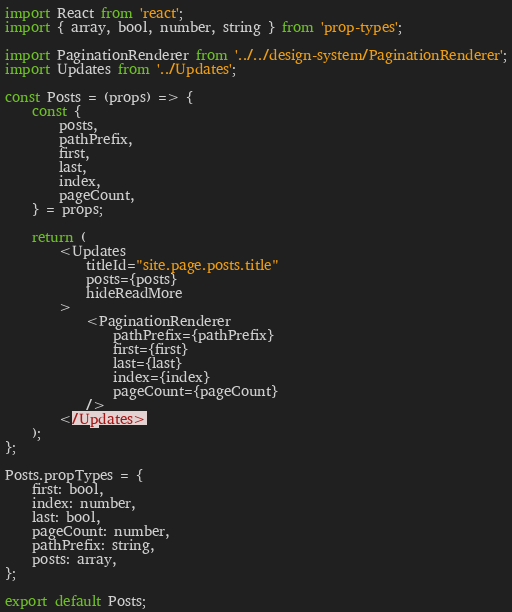Convert code to text. <code><loc_0><loc_0><loc_500><loc_500><_JavaScript_>import React from 'react';
import { array, bool, number, string } from 'prop-types';

import PaginationRenderer from '../../design-system/PaginationRenderer';
import Updates from '../Updates';

const Posts = (props) => {
	const {
		posts,
		pathPrefix,
		first,
		last,
		index,
		pageCount,
	} = props;

	return (
		<Updates
			titleId="site.page.posts.title"
			posts={posts}
			hideReadMore
		>
			<PaginationRenderer
				pathPrefix={pathPrefix}
				first={first}
				last={last}
				index={index}
				pageCount={pageCount}
			/>
		</Updates>
	);
};

Posts.propTypes = {
	first: bool,
	index: number,
	last: bool,
	pageCount: number,
	pathPrefix: string,
	posts: array,
};

export default Posts;</code> 